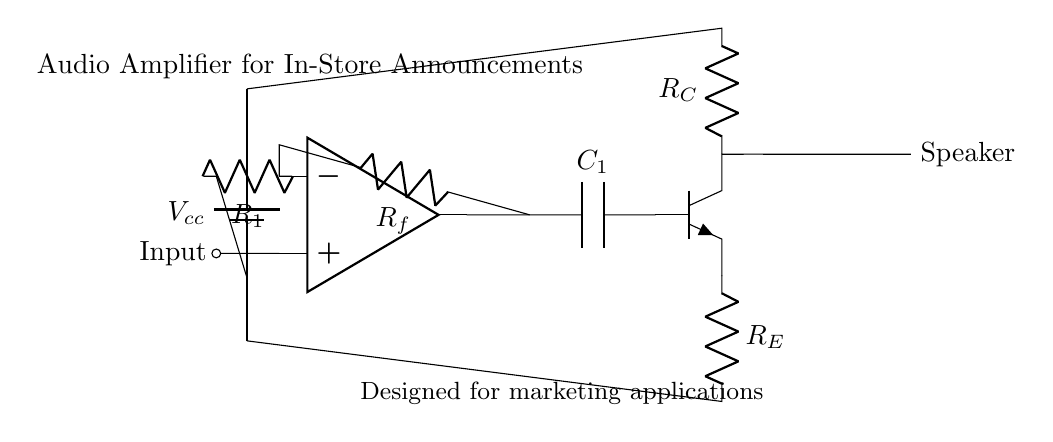What is the voltage source in this circuit? The voltage source is represented by the battery symbol and is denoted as Vcc, indicating the supply voltage provided to the circuit.
Answer: Vcc What is the purpose of the resistor R1? Resistor R1 is connected to the non-inverting input of the operational amplifier and is used to set the input impedance of the amplifier.
Answer: Input impedance How many operational amplifiers are in this circuit? The diagram shows one operational amplifier represented by the op amp symbol, which is essential for signal amplification.
Answer: One What component is used for feedback in the circuit? The feedback element is Rf, which connects the output of the operational amplifier back to its inverting input, allowing for gain control.
Answer: Rf What type of load is connected at the output? The output is connected to a speaker, indicated by the label in the circuit, which is used to deliver the amplified audio to the environment.
Answer: Speaker Why is a capacitor C1 used in the output stage? Capacitor C1 is used to block DC voltages while allowing AC signals (audio signals) to pass through, effectively coupling the amplifier output to the speaker.
Answer: Block DC What is the role of transistor Q1 in this circuit? Transistor Q1 serves as a signal amplifier, boosting the output from the operational amplifier before sending it to the speaker, increasing overall power to drive the load.
Answer: Signal amplification 